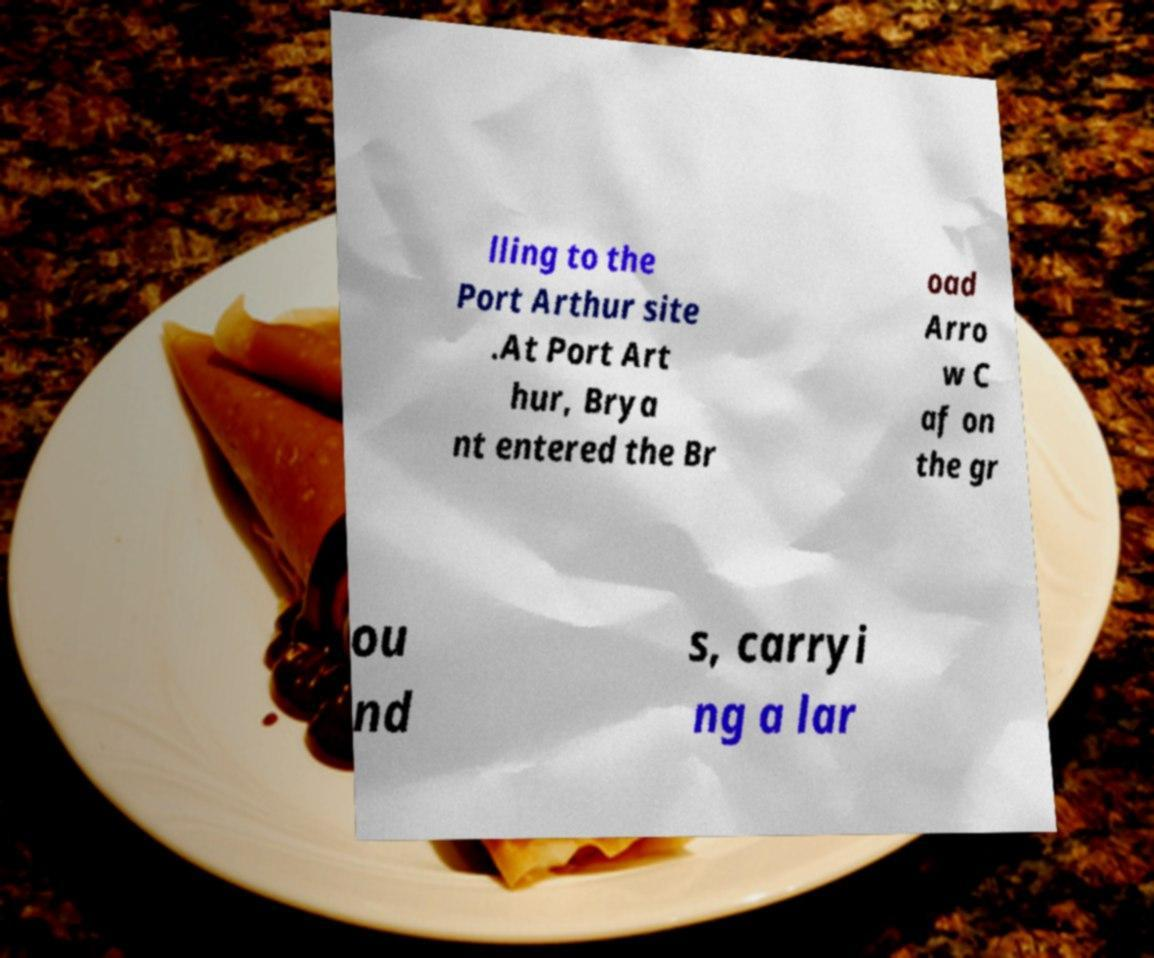What messages or text are displayed in this image? I need them in a readable, typed format. lling to the Port Arthur site .At Port Art hur, Brya nt entered the Br oad Arro w C af on the gr ou nd s, carryi ng a lar 